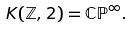Convert formula to latex. <formula><loc_0><loc_0><loc_500><loc_500>K ( \mathbb { Z } , 2 ) = \mathbb { C P } ^ { \infty } .</formula> 